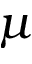<formula> <loc_0><loc_0><loc_500><loc_500>\mu</formula> 